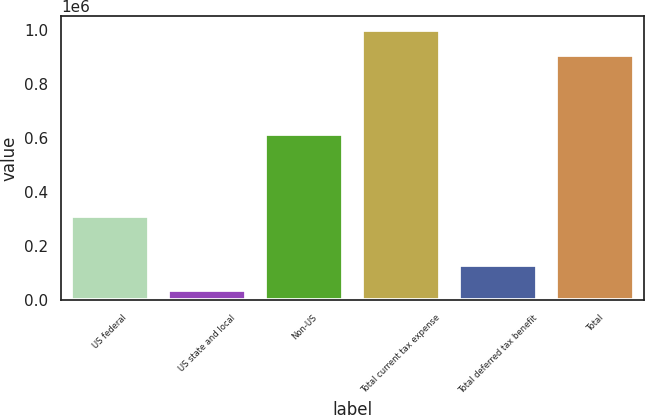Convert chart. <chart><loc_0><loc_0><loc_500><loc_500><bar_chart><fcel>US federal<fcel>US state and local<fcel>Non-US<fcel>Total current tax expense<fcel>Total deferred tax benefit<fcel>Total<nl><fcel>311270<fcel>37774<fcel>615306<fcel>1.00323e+06<fcel>130432<fcel>910574<nl></chart> 